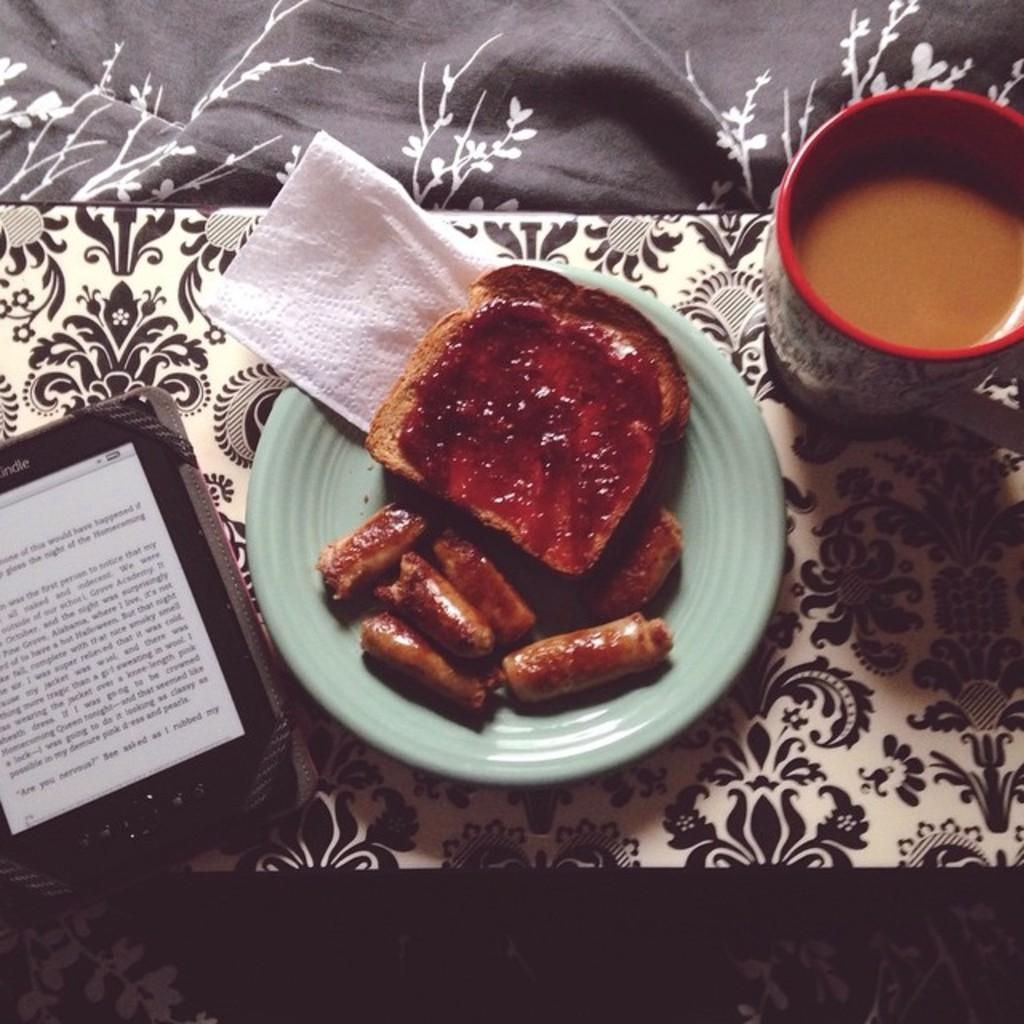Provide a one-sentence caption for the provided image. A Kindle device sits next to a plate of sausages and toast. 